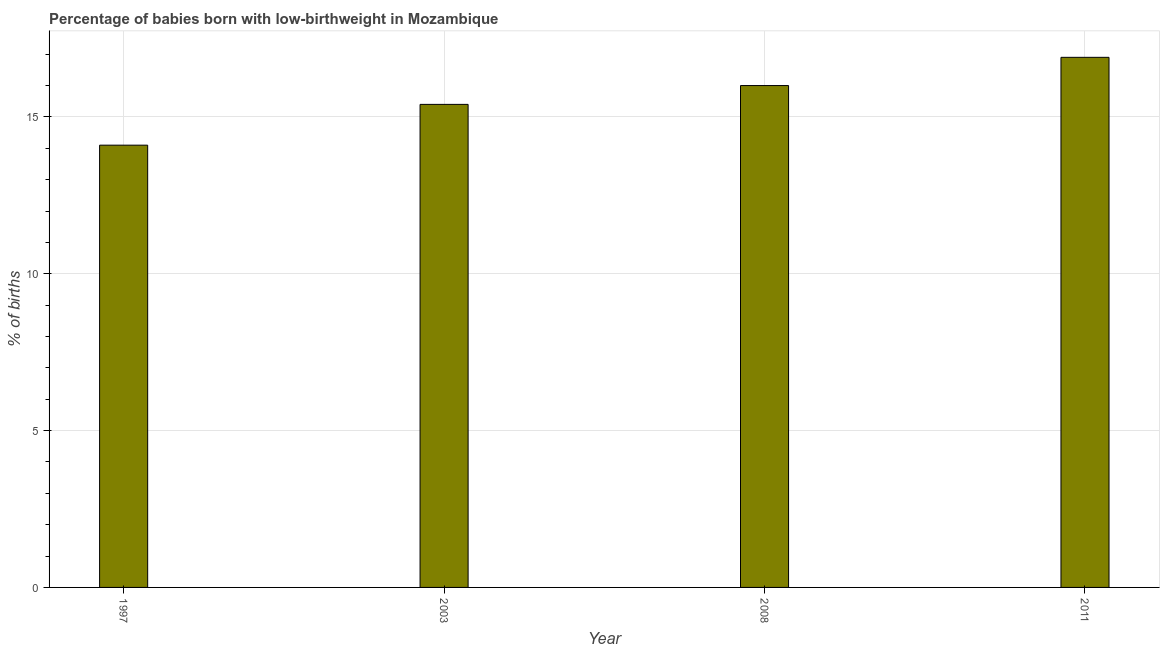Does the graph contain grids?
Offer a terse response. Yes. What is the title of the graph?
Provide a succinct answer. Percentage of babies born with low-birthweight in Mozambique. What is the label or title of the X-axis?
Provide a short and direct response. Year. What is the label or title of the Y-axis?
Your answer should be very brief. % of births. Across all years, what is the minimum percentage of babies who were born with low-birthweight?
Offer a terse response. 14.1. In which year was the percentage of babies who were born with low-birthweight maximum?
Keep it short and to the point. 2011. What is the sum of the percentage of babies who were born with low-birthweight?
Offer a very short reply. 62.4. What is the difference between the percentage of babies who were born with low-birthweight in 1997 and 2011?
Make the answer very short. -2.8. What is the average percentage of babies who were born with low-birthweight per year?
Your answer should be very brief. 15.6. What is the median percentage of babies who were born with low-birthweight?
Provide a succinct answer. 15.7. What is the ratio of the percentage of babies who were born with low-birthweight in 2008 to that in 2011?
Provide a short and direct response. 0.95. Is the sum of the percentage of babies who were born with low-birthweight in 1997 and 2011 greater than the maximum percentage of babies who were born with low-birthweight across all years?
Your answer should be compact. Yes. What is the difference between the highest and the lowest percentage of babies who were born with low-birthweight?
Make the answer very short. 2.8. How many bars are there?
Offer a terse response. 4. Are all the bars in the graph horizontal?
Your answer should be compact. No. How many years are there in the graph?
Provide a succinct answer. 4. What is the % of births in 1997?
Offer a very short reply. 14.1. What is the % of births in 2003?
Keep it short and to the point. 15.4. What is the % of births of 2008?
Ensure brevity in your answer.  16. What is the difference between the % of births in 1997 and 2011?
Keep it short and to the point. -2.8. What is the difference between the % of births in 2003 and 2008?
Your answer should be very brief. -0.6. What is the difference between the % of births in 2003 and 2011?
Offer a terse response. -1.5. What is the ratio of the % of births in 1997 to that in 2003?
Keep it short and to the point. 0.92. What is the ratio of the % of births in 1997 to that in 2008?
Make the answer very short. 0.88. What is the ratio of the % of births in 1997 to that in 2011?
Offer a terse response. 0.83. What is the ratio of the % of births in 2003 to that in 2011?
Keep it short and to the point. 0.91. What is the ratio of the % of births in 2008 to that in 2011?
Your response must be concise. 0.95. 